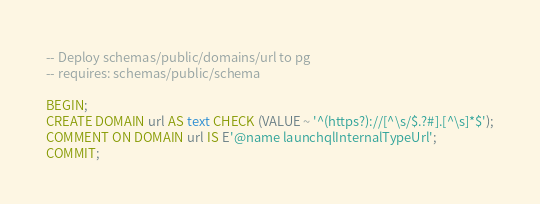<code> <loc_0><loc_0><loc_500><loc_500><_SQL_>-- Deploy schemas/public/domains/url to pg
-- requires: schemas/public/schema

BEGIN;
CREATE DOMAIN url AS text CHECK (VALUE ~ '^(https?)://[^\s/$.?#].[^\s]*$');
COMMENT ON DOMAIN url IS E'@name launchqlInternalTypeUrl';
COMMIT;

</code> 